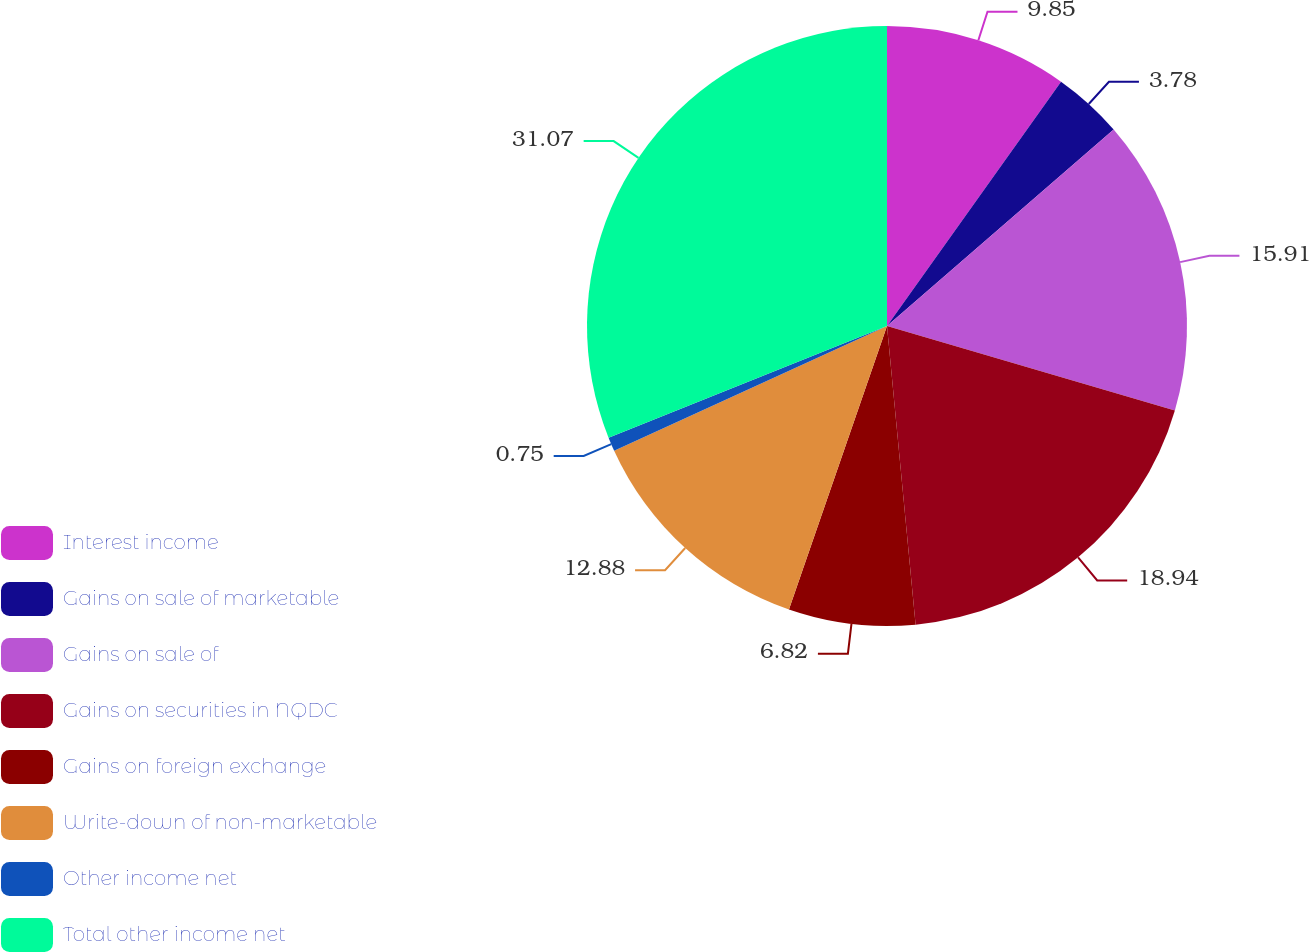Convert chart. <chart><loc_0><loc_0><loc_500><loc_500><pie_chart><fcel>Interest income<fcel>Gains on sale of marketable<fcel>Gains on sale of<fcel>Gains on securities in NQDC<fcel>Gains on foreign exchange<fcel>Write-down of non-marketable<fcel>Other income net<fcel>Total other income net<nl><fcel>9.85%<fcel>3.78%<fcel>15.91%<fcel>18.94%<fcel>6.82%<fcel>12.88%<fcel>0.75%<fcel>31.07%<nl></chart> 